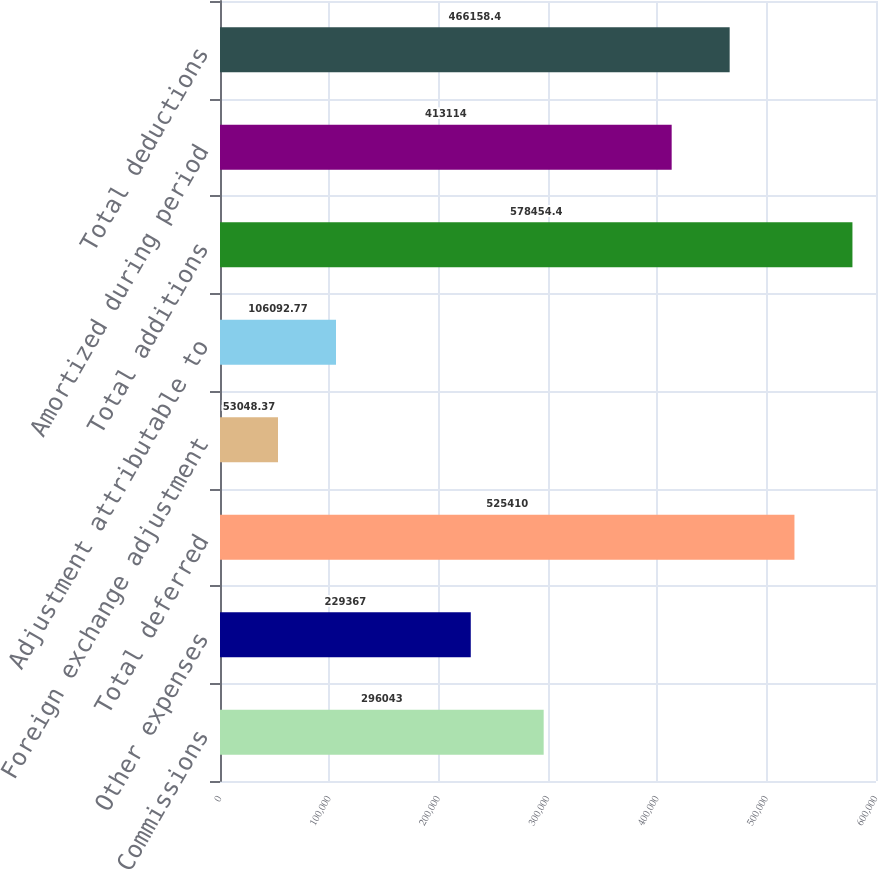Convert chart. <chart><loc_0><loc_0><loc_500><loc_500><bar_chart><fcel>Commissions<fcel>Other expenses<fcel>Total deferred<fcel>Foreign exchange adjustment<fcel>Adjustment attributable to<fcel>Total additions<fcel>Amortized during period<fcel>Total deductions<nl><fcel>296043<fcel>229367<fcel>525410<fcel>53048.4<fcel>106093<fcel>578454<fcel>413114<fcel>466158<nl></chart> 